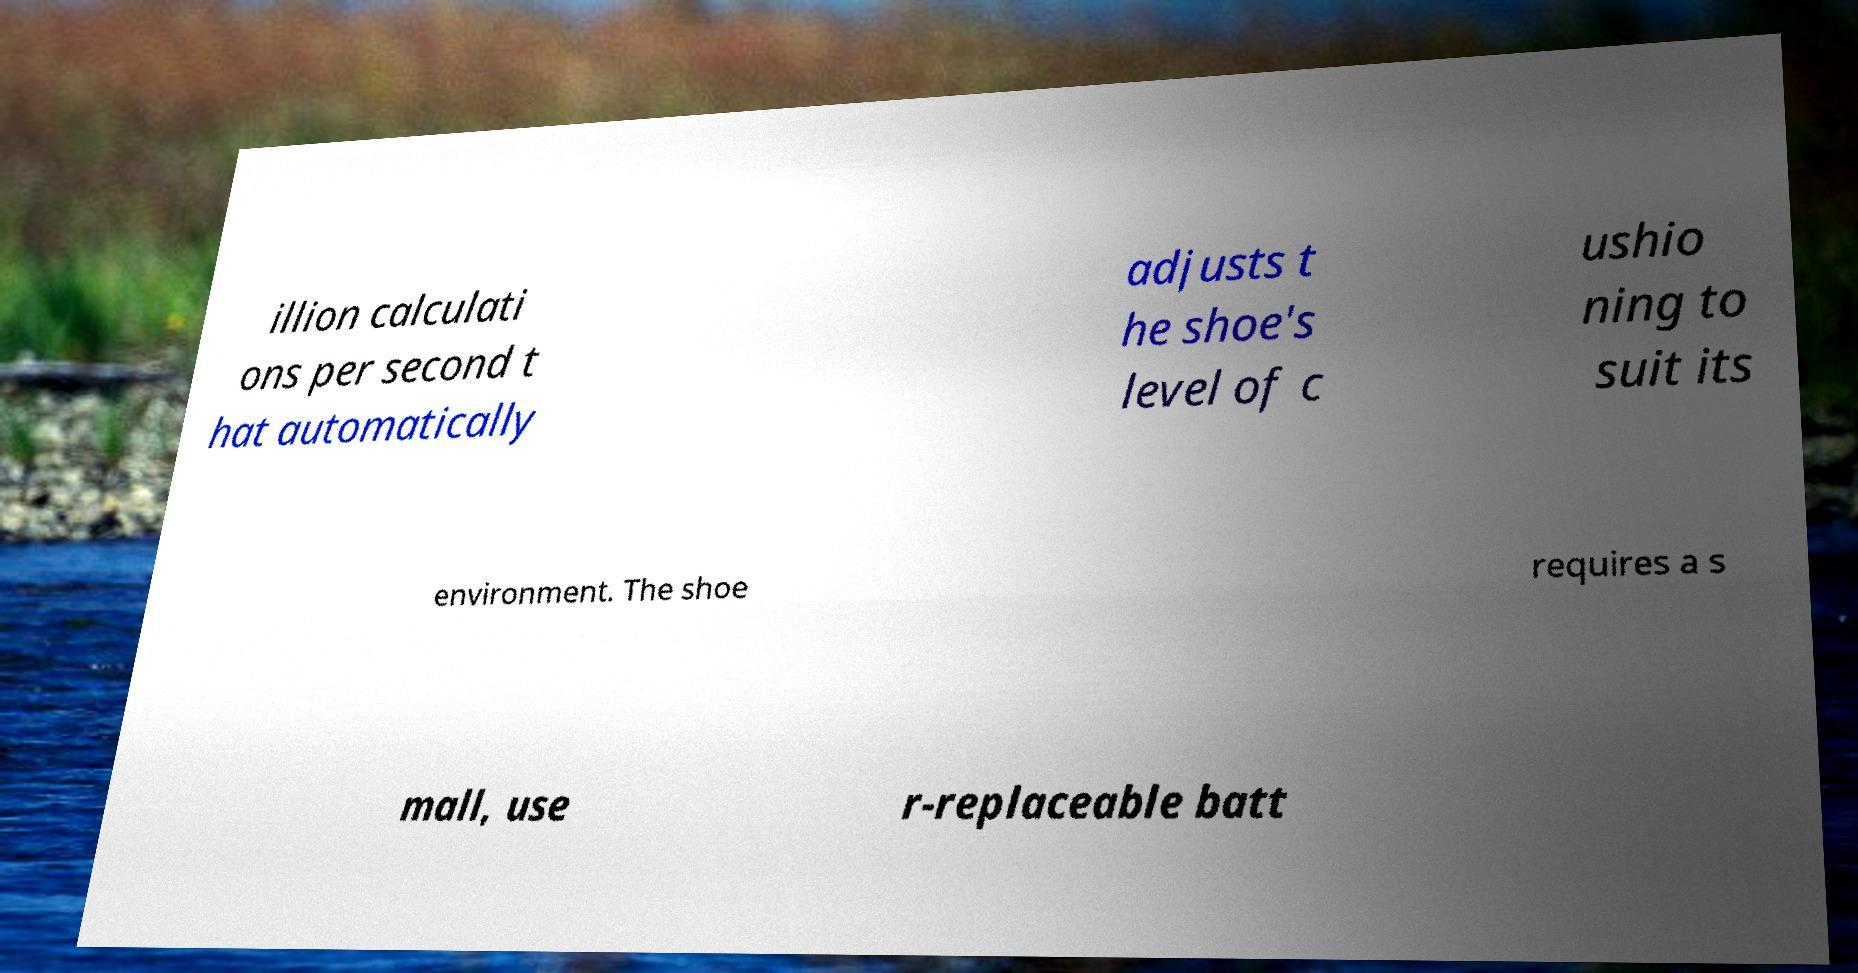Could you extract and type out the text from this image? illion calculati ons per second t hat automatically adjusts t he shoe's level of c ushio ning to suit its environment. The shoe requires a s mall, use r-replaceable batt 